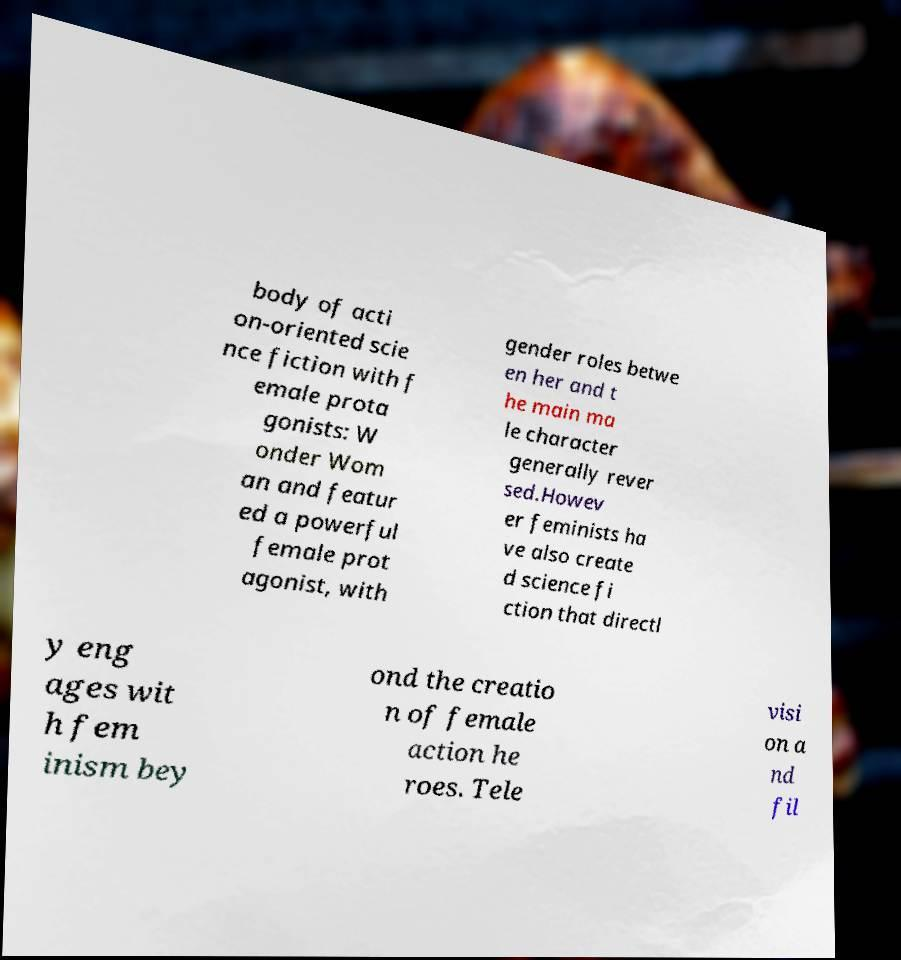Please identify and transcribe the text found in this image. body of acti on-oriented scie nce fiction with f emale prota gonists: W onder Wom an and featur ed a powerful female prot agonist, with gender roles betwe en her and t he main ma le character generally rever sed.Howev er feminists ha ve also create d science fi ction that directl y eng ages wit h fem inism bey ond the creatio n of female action he roes. Tele visi on a nd fil 